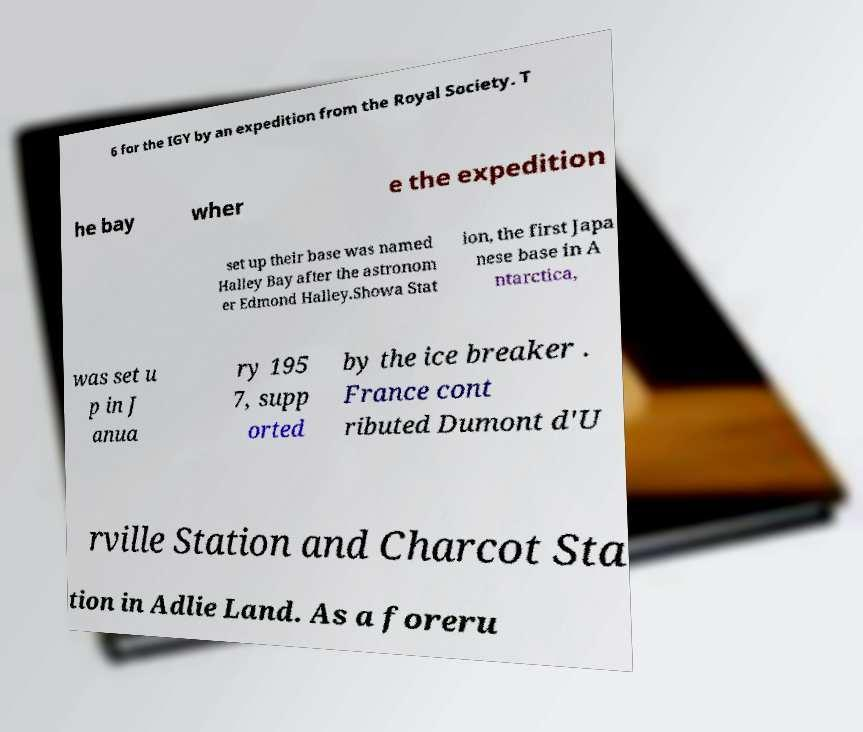Could you extract and type out the text from this image? 6 for the IGY by an expedition from the Royal Society. T he bay wher e the expedition set up their base was named Halley Bay after the astronom er Edmond Halley.Showa Stat ion, the first Japa nese base in A ntarctica, was set u p in J anua ry 195 7, supp orted by the ice breaker . France cont ributed Dumont d'U rville Station and Charcot Sta tion in Adlie Land. As a foreru 